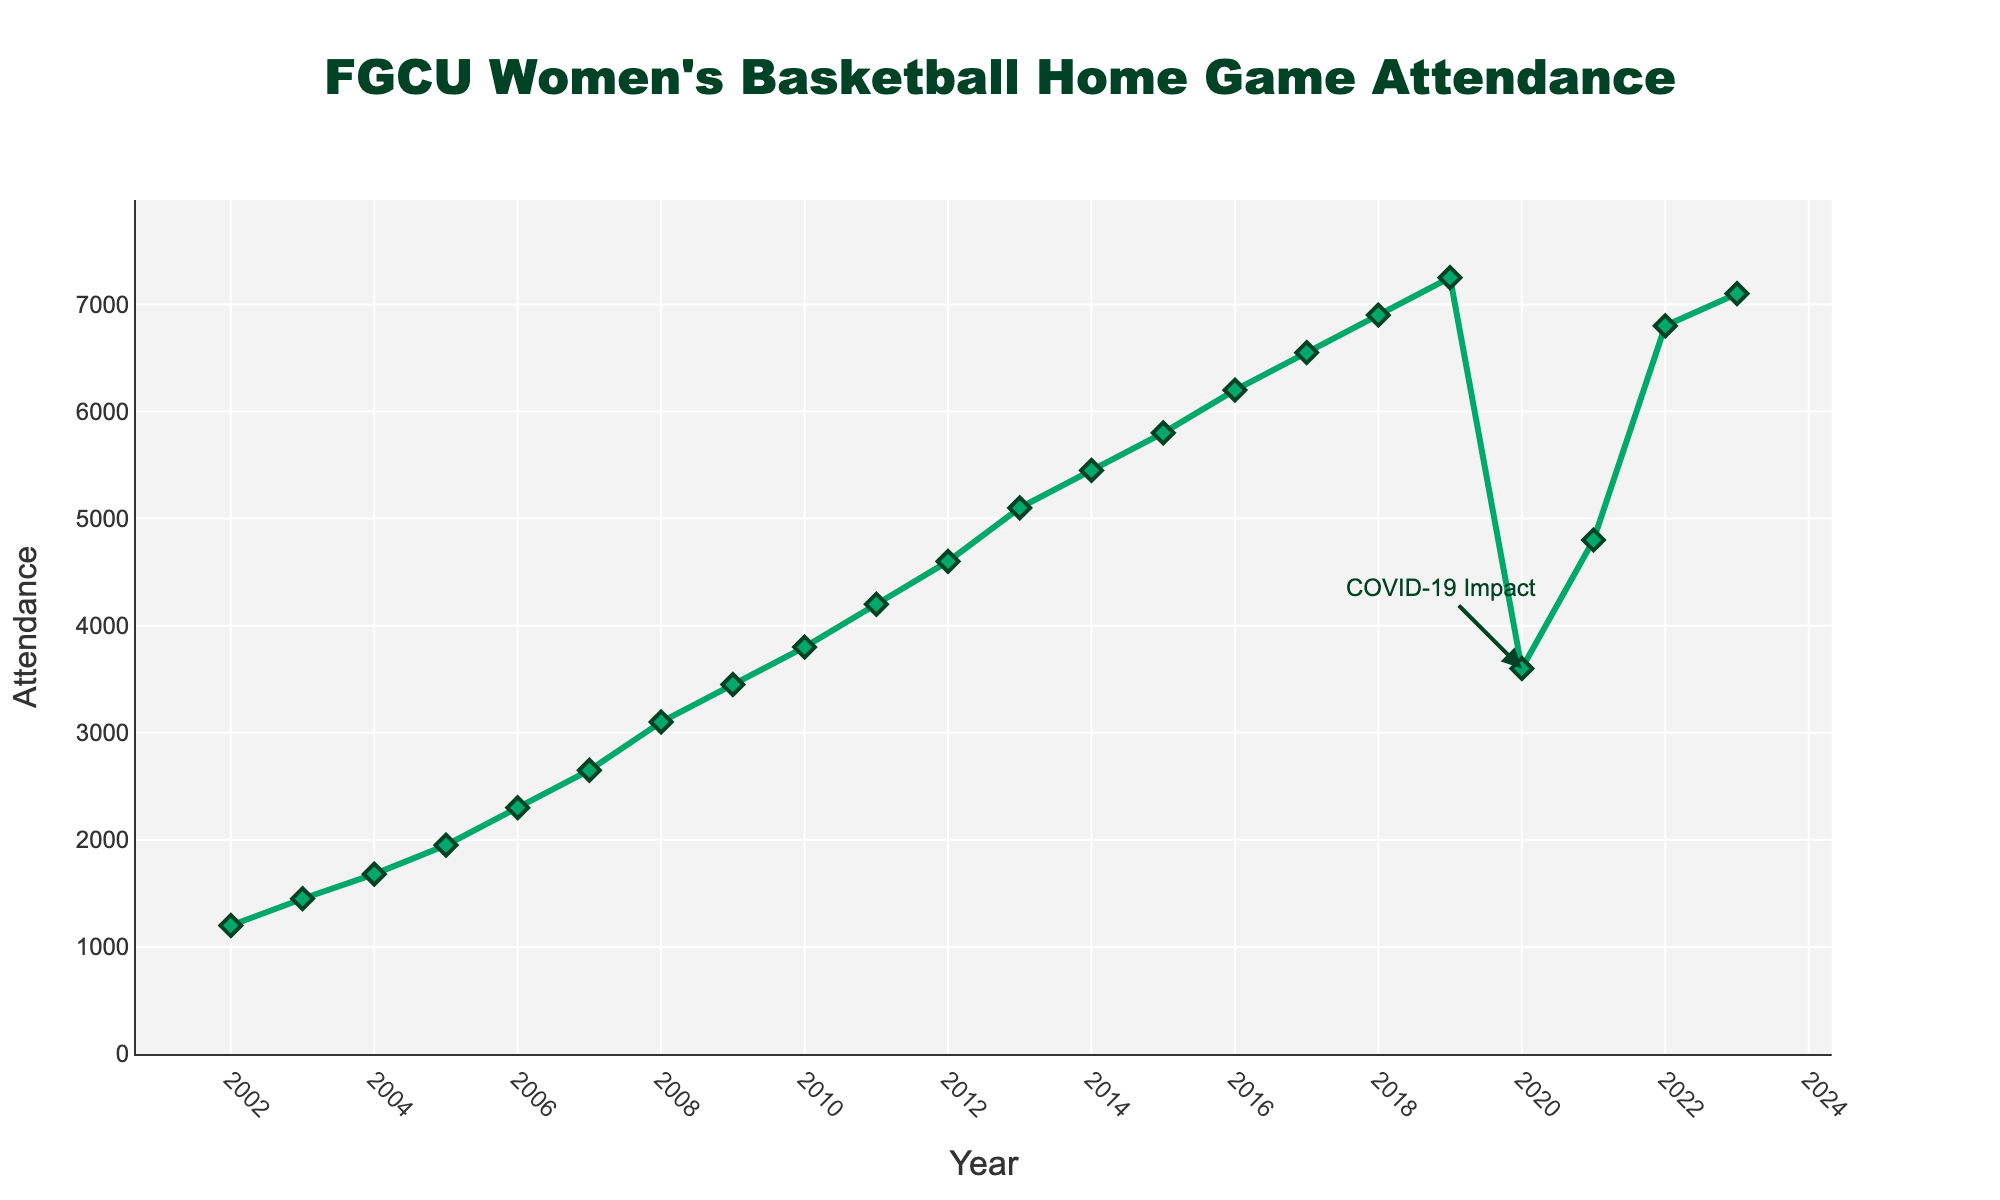What's the overall trend in FGCU Women's Basketball home game attendance from 2002 to 2023? Overall, there is a strong increasing trend in attendance figures from 1200 in 2002 to 7100 in 2023, despite some fluctuations.
Answer: Increasing What is the lowest attendance figure recorded and in which year did it occur? The lowest attendance figure recorded is 1200, which occurred in the year 2002.
Answer: 1200 in 2002 Which year had the highest attendance figure and what was the value? The highest attendance figure was recorded in 2023, with 7100 attendees.
Answer: 7100 in 2023 How did the attendance figure change between 2019 and 2020, and what might have influenced this change? Between 2019 and 2020, the attendance figure dropped from 7250 to 3600, a significant decline likely due to the COVID-19 pandemic.
Answer: Dropped by 3650, likely due to COVID-19 What is the average annual attendance figure from 2002 to 2023? To find the average, sum up all attendance figures from 2002 to 2023 and divide by the number of years. The total sum is (1200+1450+1680+1950+2300+2650+3100+3450+3800+4200+4600+5100+5450+5800+6200+6550+6900+7250+3600+4800+6800+7100) = 94830, divided by 22 years: 94830/22 ≈ 4310.
Answer: 4310 Compare the attendance in 2006 with 2012, which year had higher attendance and by what amount? In 2006, the attendance was 2300, and in 2012, it was 4600. Therefore, 2012 had higher attendance by 4600 - 2300 = 2300.
Answer: 2012 by 2300 What was the median attendance figure from 2002 to 2023? To find the median, list the attendance figures in ascending order and find the middle value. The sorted figures are [1200, 1450, 1680, 1950, 2300, 2650, 3100, 3450, 3600, 3800, 4200, 4600, 4800, 5100, 5450, 5800, 6200, 6550, 6800, 6900, 7100, 7250]. With 22 data points, the median is the average of 11th and 12th values, (4200 + 4600) / 2 = 4400.
Answer: 4400 Between which consecutive years did the attendance increase the most, and by how much? The largest increase occurred between 2021 and 2022, where attendance went from 4800 to 6800, an increase of 6800 - 4800 = 2000.
Answer: 2021 to 2022 by 2000 By what percentage did the attendance decrease from 2019 to 2020? To calculate the percentage decrease: [(7250 - 3600) / 7250] * 100 = (3650 / 7250) * 100 ≈ 50.34%.
Answer: ≈ 50.34% What visual feature on the plot indicates the impact of COVID-19? There is an annotation at the point corresponding to the year 2020, highlighting "COVID-19 Impact".
Answer: COVID-19 Impact annotation 